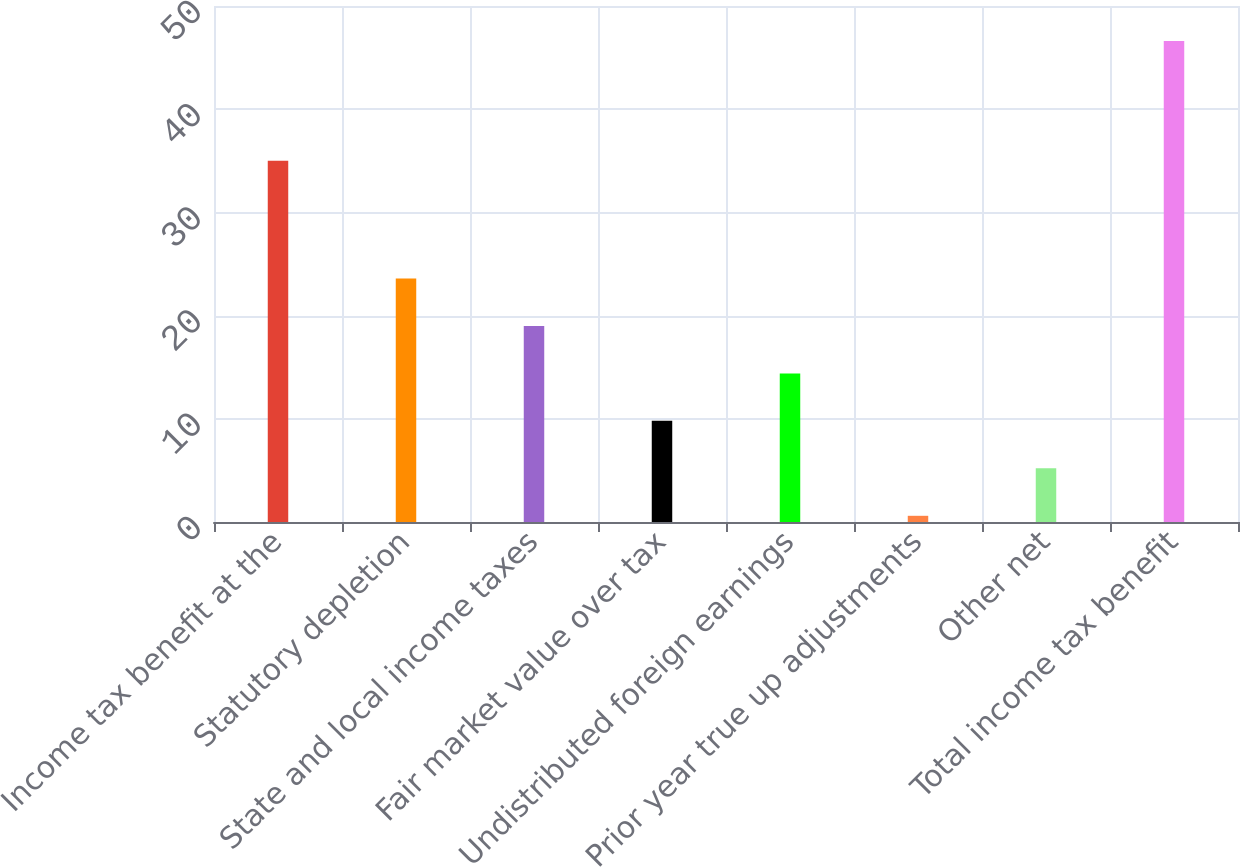<chart> <loc_0><loc_0><loc_500><loc_500><bar_chart><fcel>Income tax benefit at the<fcel>Statutory depletion<fcel>State and local income taxes<fcel>Fair market value over tax<fcel>Undistributed foreign earnings<fcel>Prior year true up adjustments<fcel>Other net<fcel>Total income tax benefit<nl><fcel>35<fcel>23.6<fcel>19<fcel>9.8<fcel>14.4<fcel>0.6<fcel>5.2<fcel>46.6<nl></chart> 